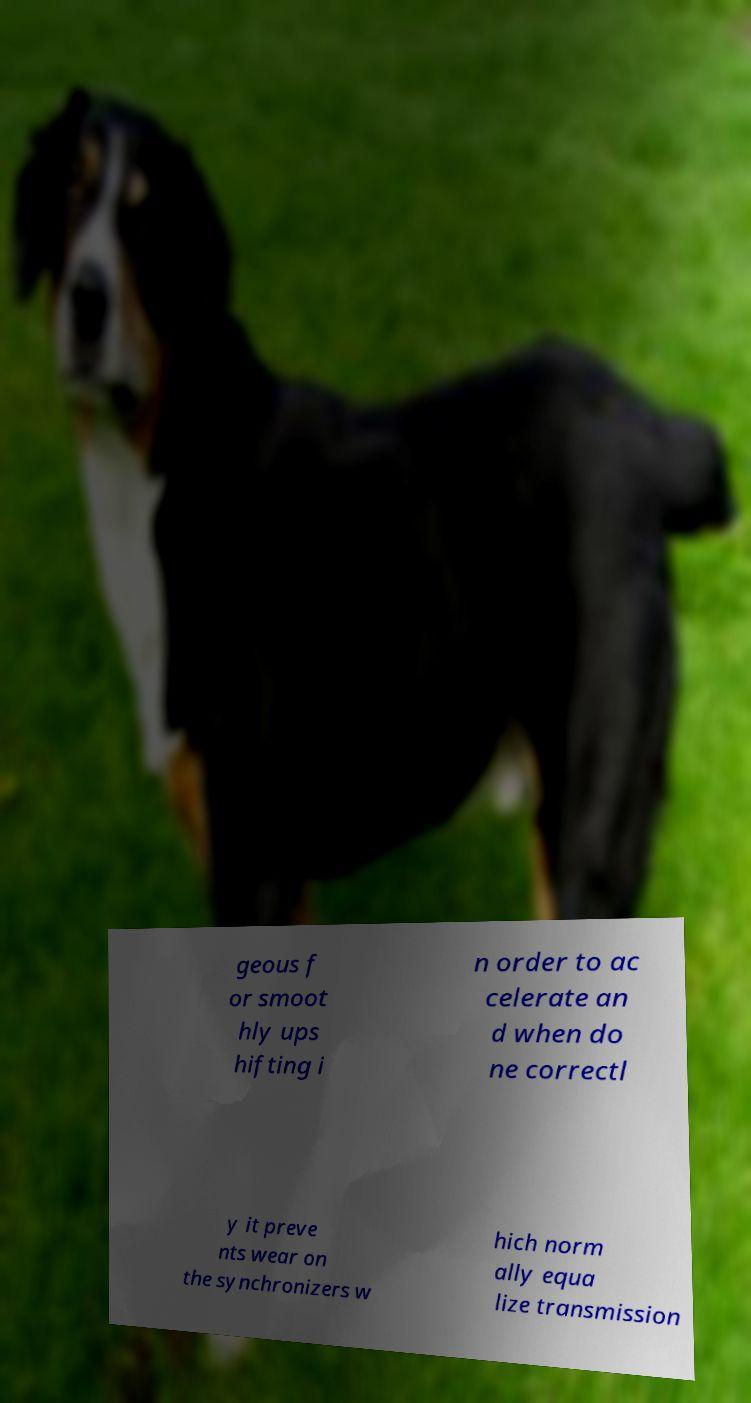For documentation purposes, I need the text within this image transcribed. Could you provide that? geous f or smoot hly ups hifting i n order to ac celerate an d when do ne correctl y it preve nts wear on the synchronizers w hich norm ally equa lize transmission 